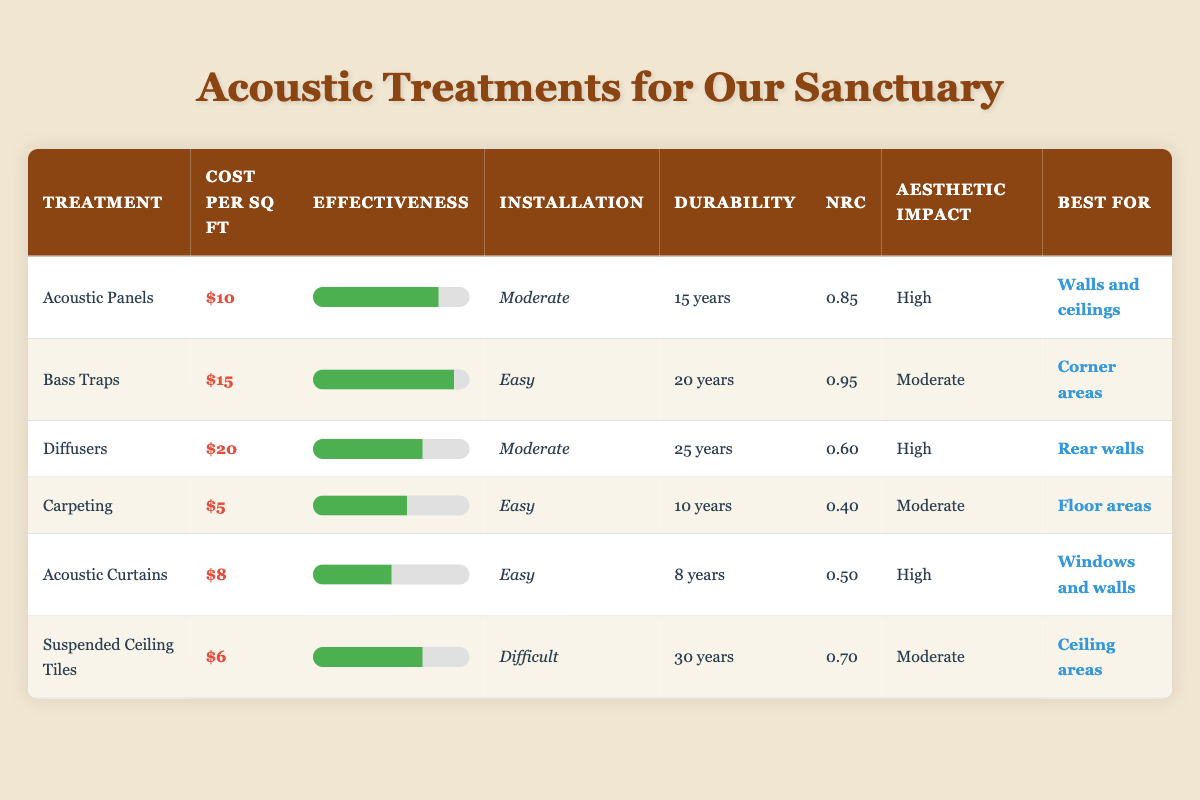What is the cost per square foot of Bass Traps? The table lists the cost per square foot for Bass Traps, which is clearly indicated in the "Cost per sq ft" column. The entry for Bass Traps shows a cost of $15.
Answer: $15 Which treatment has the highest noise reduction coefficient? By looking at the "NRC" column, the highest value listed is 0.95, which corresponds to Bass Traps.
Answer: Bass Traps How many treatments have an effectiveness rating of 7 or higher? We will check the "Effectiveness" ratings: Acoustic Panels (8), Bass Traps (9), Diffusers (7), and Suspended Ceiling Tiles (7) meet this criterion. Adding them up gives us 4 treatments.
Answer: 4 What is the average durability (in years) of the acoustic treatments? We sum the durability years for all treatments: (15 + 20 + 25 + 10 + 8 + 30) = 108 years across 6 treatments. Thus, the average is 108 / 6 = 18 years.
Answer: 18 years Is it true that Carpeting has a higher effectiveness rating than Acoustic Curtains? We compare their effectiveness ratings: Carpeting has a rating of 6, while Acoustic Curtains have a rating of 5. Since 6 is greater than 5, the statement is true.
Answer: Yes Which treatment has the lowest cost and what is its effectiveness? The cost per square foot is lowest for Carpeting at $5, and its effectiveness rating is 6. So, the treatment with the lowest cost is Carpeting, and its effectiveness is 6.
Answer: Carpeting; 6 What is the effectiveness rating difference between the best and worst acoustic treatments? The best effectiveness rating is for Bass Traps with 9, and the worst is for Acoustic Curtains with 5. Therefore, the difference is 9 - 5 = 4.
Answer: 4 Which treatments have a high aesthetic impact? Checking the "Aesthetic Impact" column, we see that Acoustic Panels, Diffusers, and Acoustic Curtains are all listed as having a high aesthetic impact. Therefore, three treatments fit this criterion.
Answer: 3 Treatments How long do Acoustic Panels last compared to Suspended Ceiling Tiles? Acoustic Panels have a durability of 15 years, while Suspended Ceiling Tiles last 30 years. Consequently, Suspended Ceiling Tiles last longer by 15 years.
Answer: Suspended Ceiling Tiles last longer by 15 years 